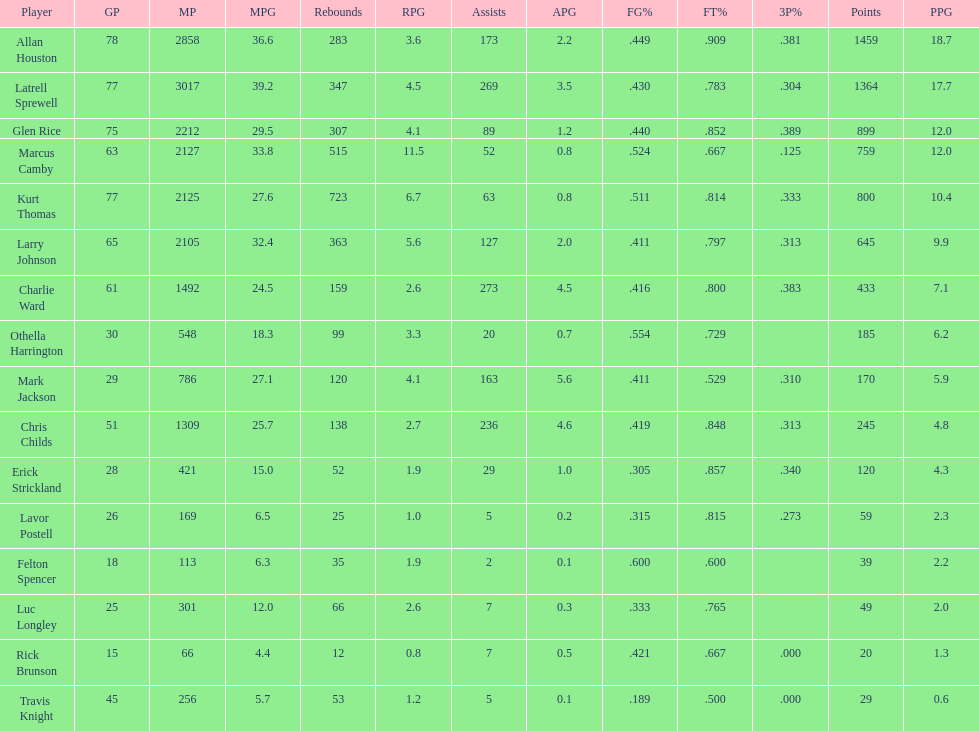How many total points were scored by players averaging over 4 assists per game> 848. 